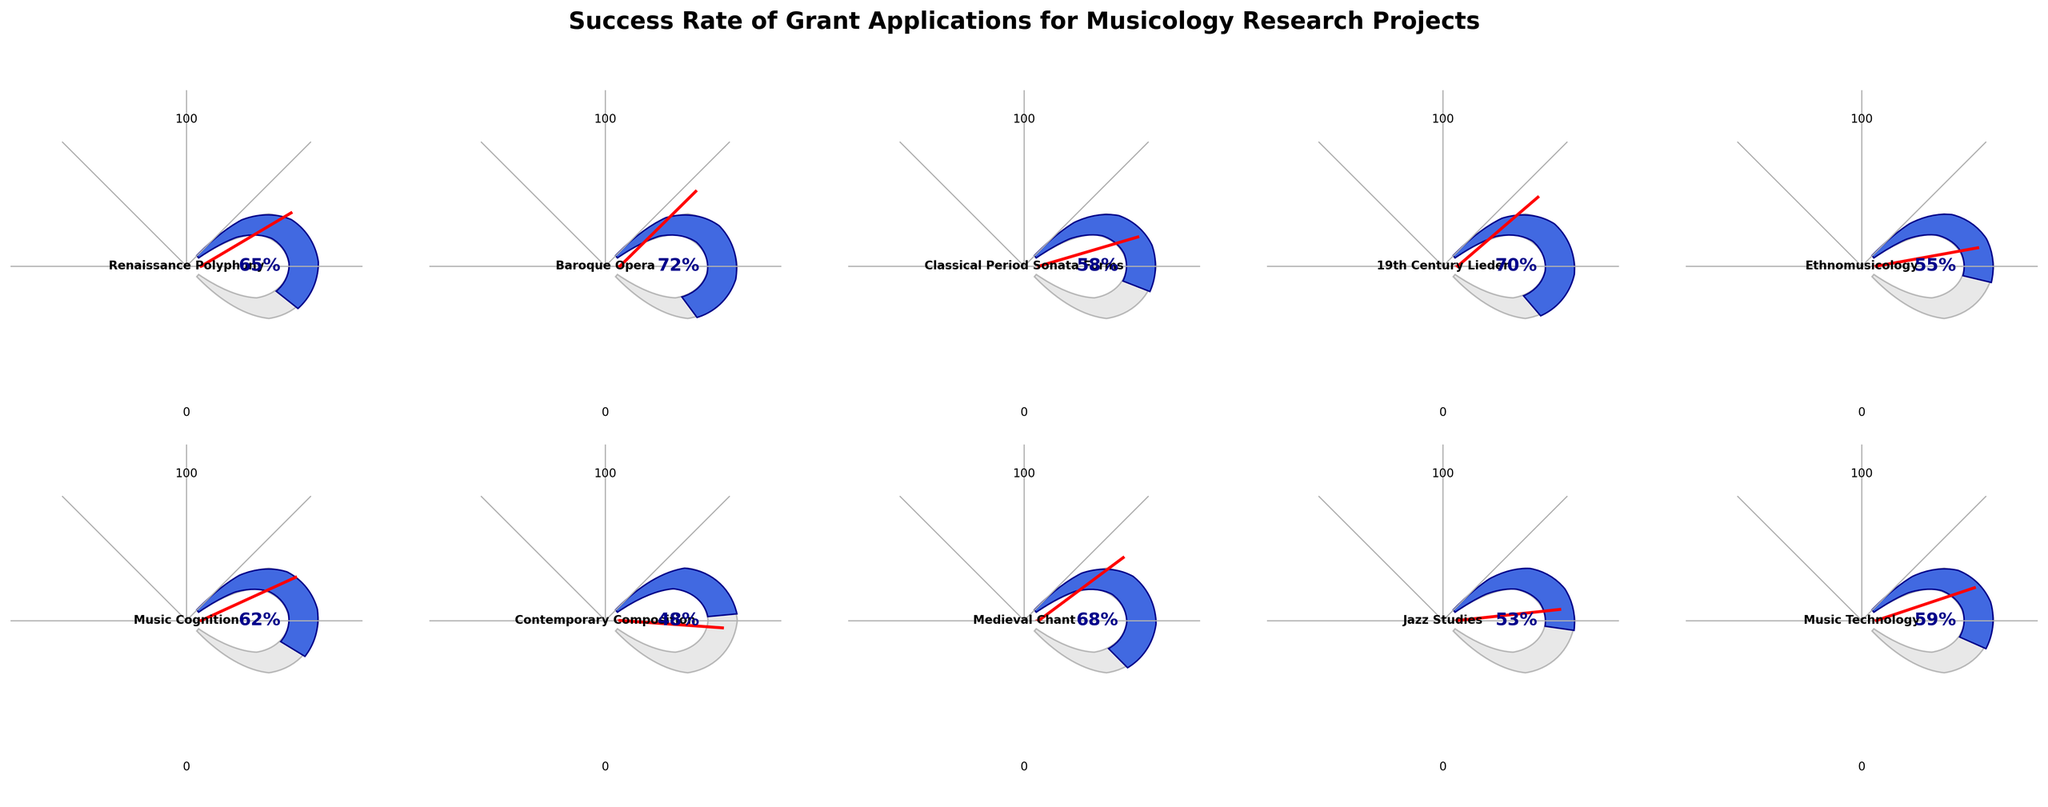Which research focus area has the highest success rate? By observing the gauge chart, we can see that the 'Baroque Opera' research focus area has the highest success rate at 72%.
Answer: Baroque Opera Which research focus area has the lowest success rate? The 'Contemporary Composition' research focus area has the lowest success rate at 48%.
Answer: Contemporary Composition Which research focus areas have a success rate above 60%? The research focus areas with a success rate above 60% are 'Renaissance Polyphony' (65%), 'Baroque Opera' (72%), '19th Century Lieder' (70%), 'Music Cognition' (62%), and 'Medieval Chant' (68%).
Answer: Renaissance Polyphony, Baroque Opera, 19th Century Lieder, Music Cognition, Medieval Chant What is the average success rate for all research focus areas? Sum all success rates: 65 + 72 + 58 + 70 + 55 + 62 + 48 + 68 + 53 + 59 = 610. There are 10 research focus areas, so the average is 610/10 = 61.
Answer: 61 What is the difference in success rates between 'Jazz Studies' and 'Music Technology'? 'Jazz Studies' has a success rate of 53%, and 'Music Technology' has 59%. The difference is 59 - 53 = 6.
Answer: 6 Which research areas have a success rate between 50% and 70%? The research areas with a success rate between 50% and 70% are 'Renaissance Polyphony' (65%), 'Classical Period Sonata Forms' (58%), '19th Century Lieder' (70%), 'Ethnomusicology' (55%), 'Music Cognition' (62%), 'Medieval Chant' (68%), 'Jazz Studies' (53%), and 'Music Technology' (59%).
Answer: Renaissance Polyphony, Classical Period Sonata Forms, 19th Century Lieder, Ethnomusicology, Music Cognition, Medieval Chant, Jazz Studies, Music Technology Which research focus area has a success rate closest to the average success rate? The average success rate is 61%. 'Music Cognition' has a success rate of 62%, which is closest to 61%.
Answer: Music Cognition What is the total number of research focus areas displayed on the gauge chart? There are 10 research focus areas displayed on the gauge chart.
Answer: 10 Which research focus area comes immediately before 'Music Technology' when listed in decreasing order of success rates? When ordered from highest to lowest success rate: Baroque Opera (72%), 19th Century Lieder (70%), Medieval Chant (68%), Renaissance Polyphony (65%), Music Cognition (62%), Classical Period Sonata Forms (58%), Music Technology (59%) is next, so immediately before it is Jazz Studies (53%).
Answer: Jazz Studies 